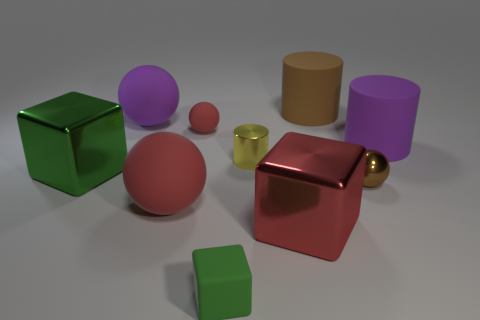Subtract all large red rubber spheres. How many spheres are left? 3 Subtract all red cubes. How many cubes are left? 2 Subtract 0 cyan cubes. How many objects are left? 10 Subtract all cylinders. How many objects are left? 7 Subtract 4 balls. How many balls are left? 0 Subtract all green blocks. Subtract all purple cylinders. How many blocks are left? 1 Subtract all green balls. How many red blocks are left? 1 Subtract all big red spheres. Subtract all big brown objects. How many objects are left? 8 Add 9 large red metallic blocks. How many large red metallic blocks are left? 10 Add 2 large shiny objects. How many large shiny objects exist? 4 